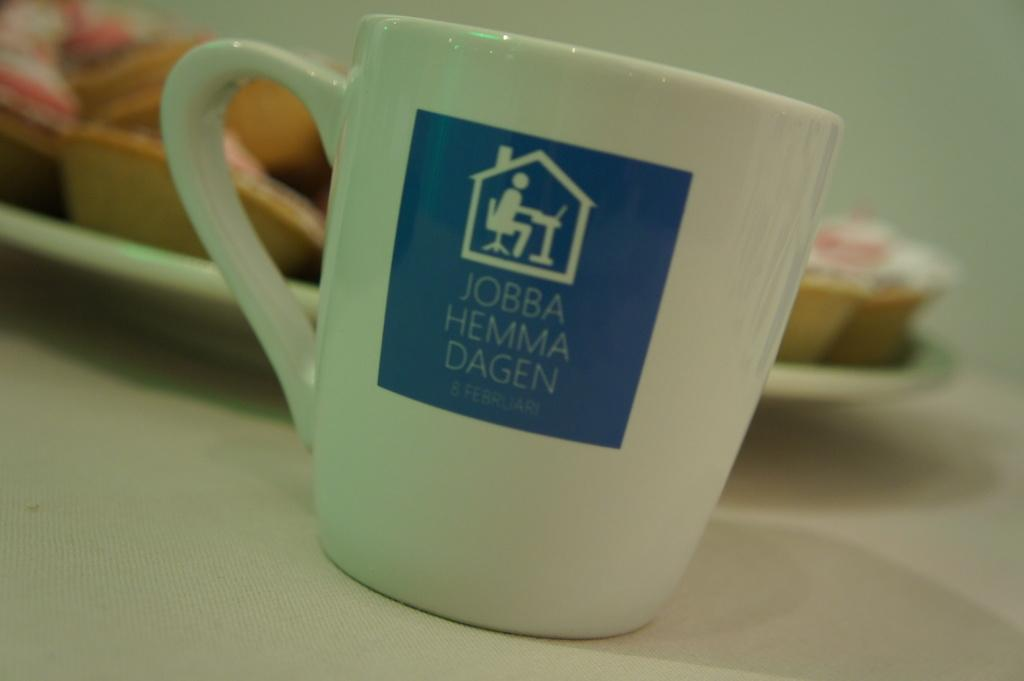<image>
Provide a brief description of the given image. A white and blue coffee cup with the words, Jobba Hemma Dagen on the front. 